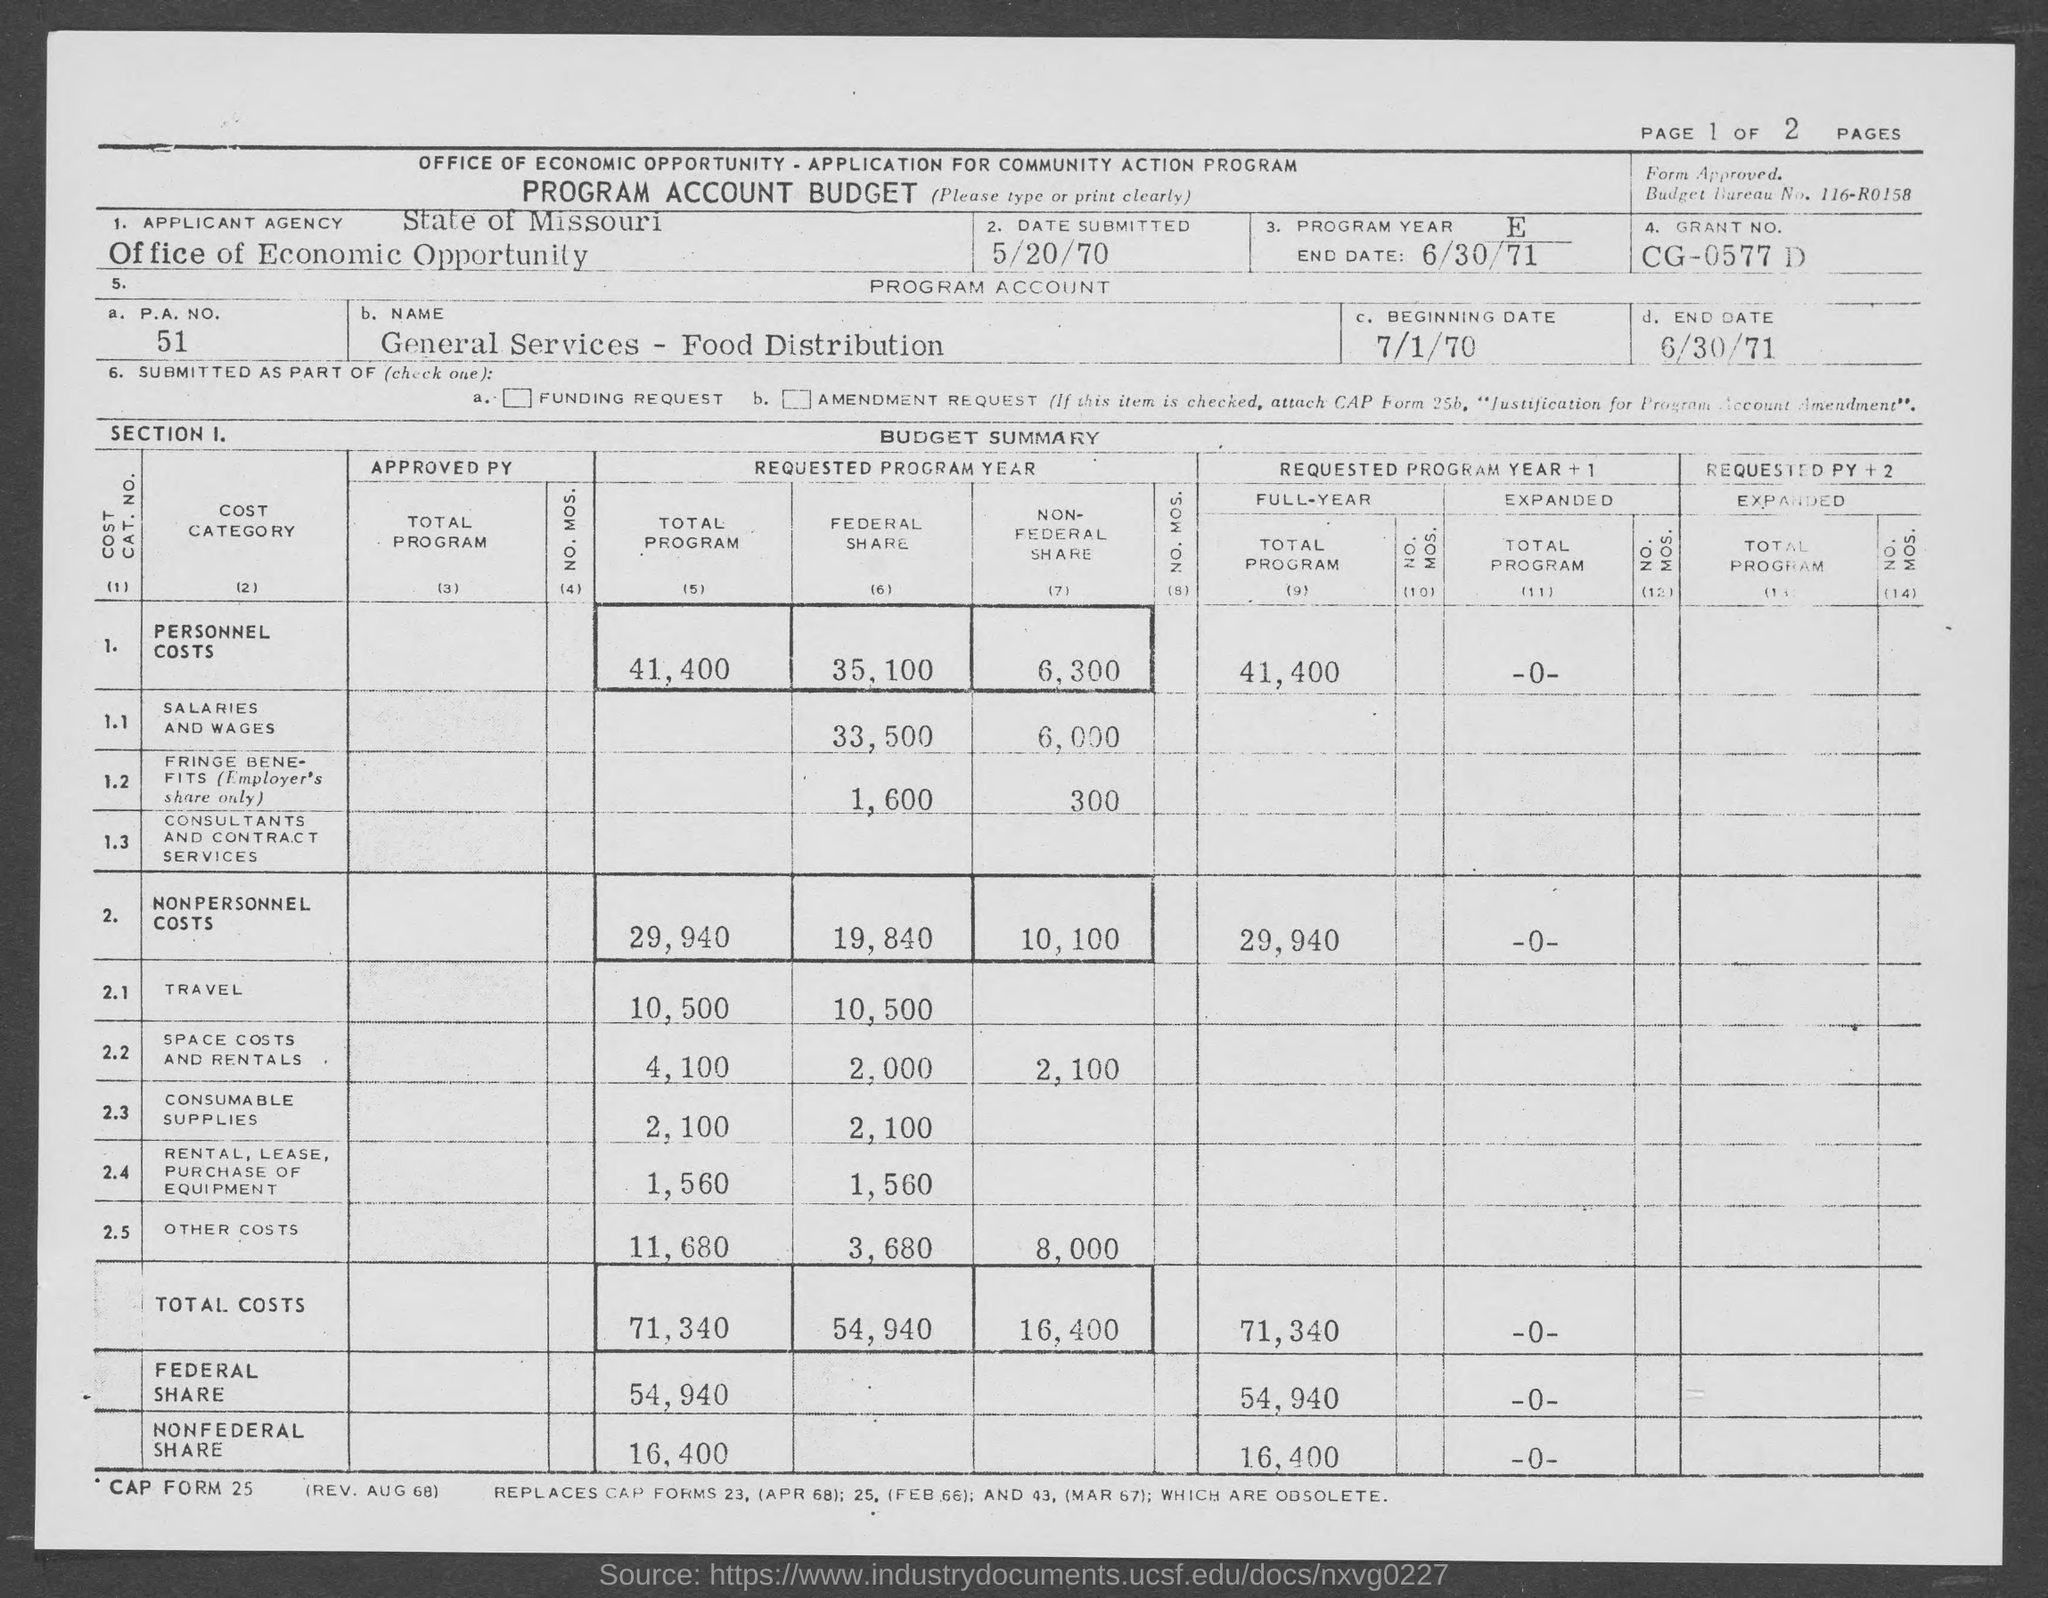Point out several critical features in this image. The P.A.No. is 51. The program is expected to conclude on June 30, 1971. The beginning date is 7/1/70. On May 20, 1970, the date of submission was. 